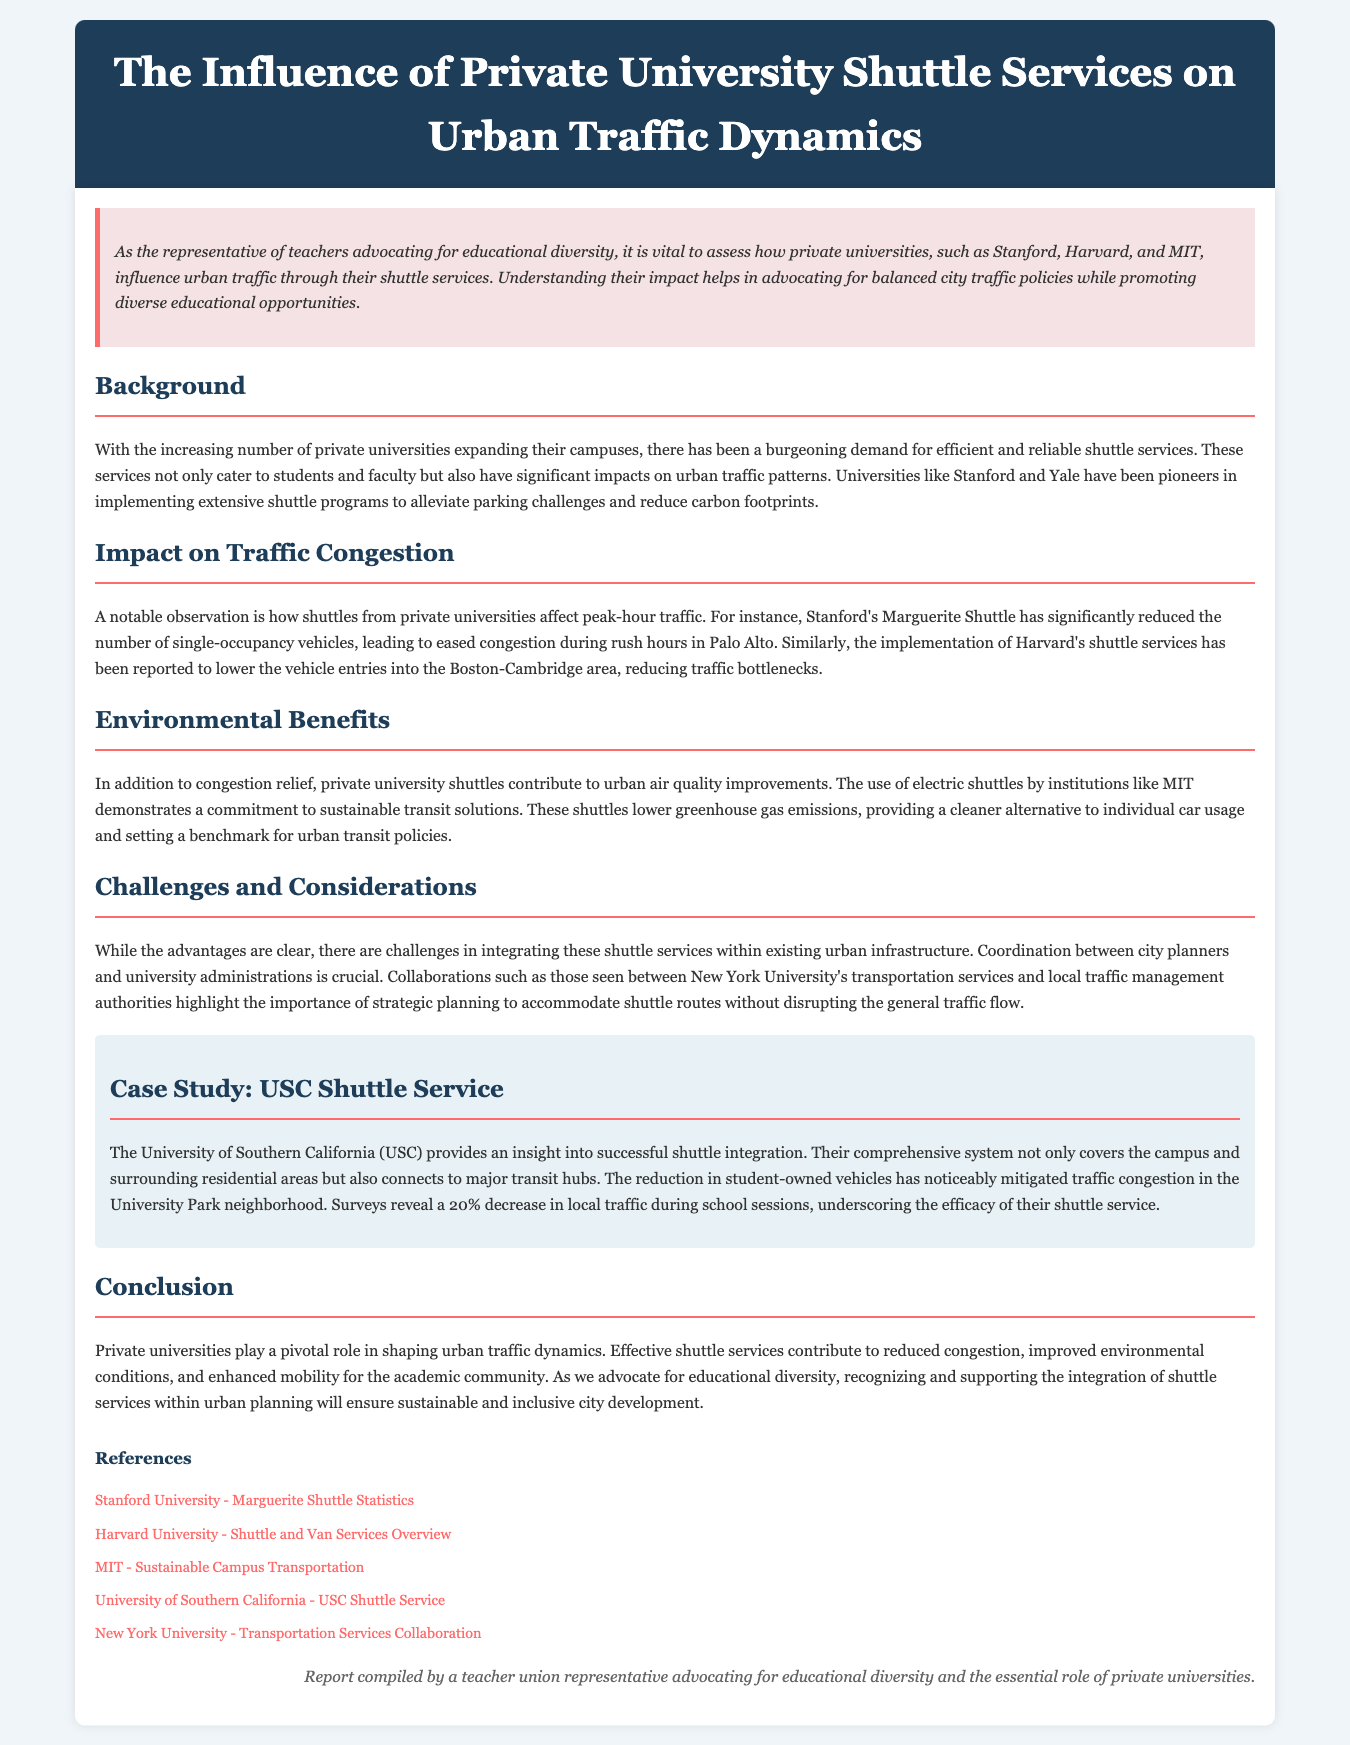What is the title of the report? The title of the report is found in the header section, which specifically states "The Influence of Private University Shuttle Services on Urban Traffic Dynamics."
Answer: The Influence of Private University Shuttle Services on Urban Traffic Dynamics Which universities are mentioned as examples in the document? The document lists Stanford, Harvard, and MIT as examples of private universities influential in urban traffic dynamics.
Answer: Stanford, Harvard, MIT What has Stanford's Marguerite Shuttle significantly reduced? The report mentions that Stanford's Marguerite Shuttle has significantly reduced the number of single-occupancy vehicles, which aids in traffic relief.
Answer: Single-occupancy vehicles What percentage decrease in local traffic does the USC shuttle service show? The USC shuttle service assessment indicates a 20% decrease in local traffic during school sessions, demonstrating its impact.
Answer: 20% What is a collaboration mentioned in the report? The document highlights a collaboration between New York University's transportation services and local traffic management authorities for effective shuttle integration.
Answer: New York University's transportation services and local traffic management authorities What challenge is mentioned regarding shuttle services? The document outlines the challenge of integrating shuttle services within existing urban infrastructure as a significant consideration.
Answer: Integrating shuttle services within existing urban infrastructure What type of shuttle is highlighted as being used by MIT? The report refers to electric shuttles used by MIT, emphasizing their environmental benefits and commitment to sustainability.
Answer: Electric shuttles What does the report suggest about private universities and urban traffic? The conclusion of the report asserts that private universities play a pivotal role in shaping urban traffic dynamics through their shuttle services.
Answer: Pivotal role 